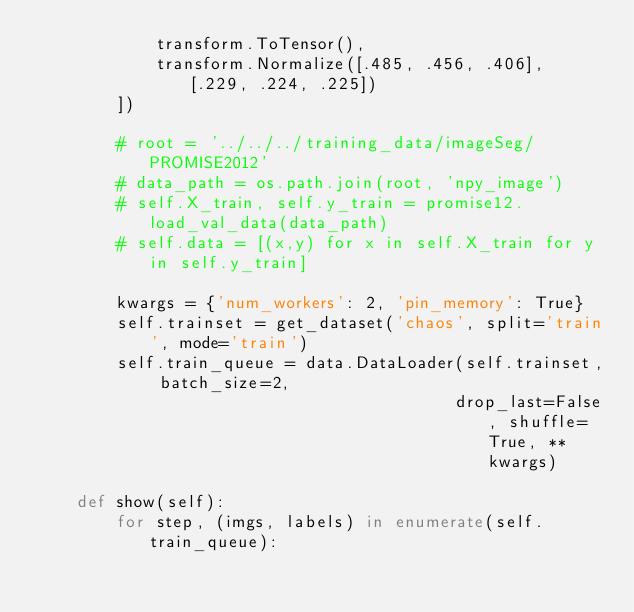Convert code to text. <code><loc_0><loc_0><loc_500><loc_500><_Python_>            transform.ToTensor(),
            transform.Normalize([.485, .456, .406], [.229, .224, .225])
        ])

        # root = '../../../training_data/imageSeg/PROMISE2012'
        # data_path = os.path.join(root, 'npy_image')
        # self.X_train, self.y_train = promise12.load_val_data(data_path)
        # self.data = [(x,y) for x in self.X_train for y in self.y_train]

        kwargs = {'num_workers': 2, 'pin_memory': True}
        self.trainset = get_dataset('chaos', split='train', mode='train')
        self.train_queue = data.DataLoader(self.trainset, batch_size=2,
                                          drop_last=False, shuffle=True, **kwargs)

    def show(self):
        for step, (imgs, labels) in enumerate(self.train_queue):</code> 